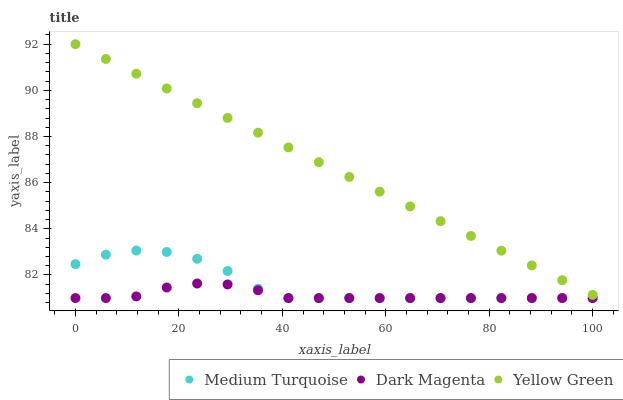Does Dark Magenta have the minimum area under the curve?
Answer yes or no. Yes. Does Yellow Green have the maximum area under the curve?
Answer yes or no. Yes. Does Medium Turquoise have the minimum area under the curve?
Answer yes or no. No. Does Medium Turquoise have the maximum area under the curve?
Answer yes or no. No. Is Yellow Green the smoothest?
Answer yes or no. Yes. Is Medium Turquoise the roughest?
Answer yes or no. Yes. Is Medium Turquoise the smoothest?
Answer yes or no. No. Is Yellow Green the roughest?
Answer yes or no. No. Does Dark Magenta have the lowest value?
Answer yes or no. Yes. Does Yellow Green have the lowest value?
Answer yes or no. No. Does Yellow Green have the highest value?
Answer yes or no. Yes. Does Medium Turquoise have the highest value?
Answer yes or no. No. Is Dark Magenta less than Yellow Green?
Answer yes or no. Yes. Is Yellow Green greater than Medium Turquoise?
Answer yes or no. Yes. Does Medium Turquoise intersect Dark Magenta?
Answer yes or no. Yes. Is Medium Turquoise less than Dark Magenta?
Answer yes or no. No. Is Medium Turquoise greater than Dark Magenta?
Answer yes or no. No. Does Dark Magenta intersect Yellow Green?
Answer yes or no. No. 